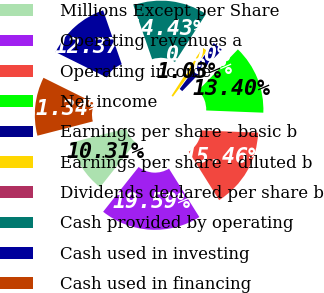Convert chart. <chart><loc_0><loc_0><loc_500><loc_500><pie_chart><fcel>Millions Except per Share<fcel>Operating revenues a<fcel>Operating income<fcel>Net income<fcel>Earnings per share - basic b<fcel>Earnings per share - diluted b<fcel>Dividends declared per share b<fcel>Cash provided by operating<fcel>Cash used in investing<fcel>Cash used in financing<nl><fcel>10.31%<fcel>19.59%<fcel>15.46%<fcel>13.4%<fcel>2.06%<fcel>1.03%<fcel>0.0%<fcel>14.43%<fcel>12.37%<fcel>11.34%<nl></chart> 